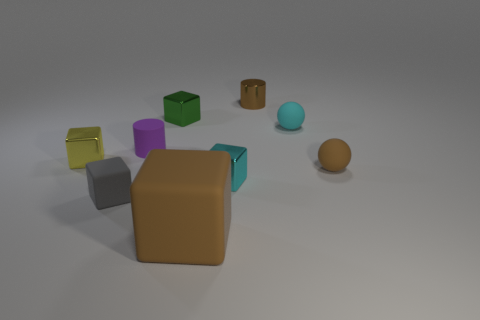What number of other things are there of the same color as the large matte thing?
Your response must be concise. 2. How many blue objects are big matte cubes or rubber cylinders?
Give a very brief answer. 0. There is a shiny thing that is on the left side of the tiny rubber cylinder; is its shape the same as the small cyan thing in front of the purple matte thing?
Your answer should be very brief. Yes. How many other objects are the same material as the tiny purple thing?
Give a very brief answer. 4. Are there any brown metal things on the left side of the tiny brown object on the left side of the rubber thing that is behind the purple matte cylinder?
Give a very brief answer. No. Are the small brown cylinder and the small gray block made of the same material?
Provide a short and direct response. No. Is there any other thing that is the same shape as the brown metal thing?
Keep it short and to the point. Yes. There is a cube in front of the small thing that is in front of the cyan block; what is its material?
Make the answer very short. Rubber. Are there an equal number of gray blocks and tiny gray matte cylinders?
Offer a terse response. No. How big is the thing on the left side of the gray cube?
Make the answer very short. Small. 